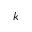Convert formula to latex. <formula><loc_0><loc_0><loc_500><loc_500>k</formula> 